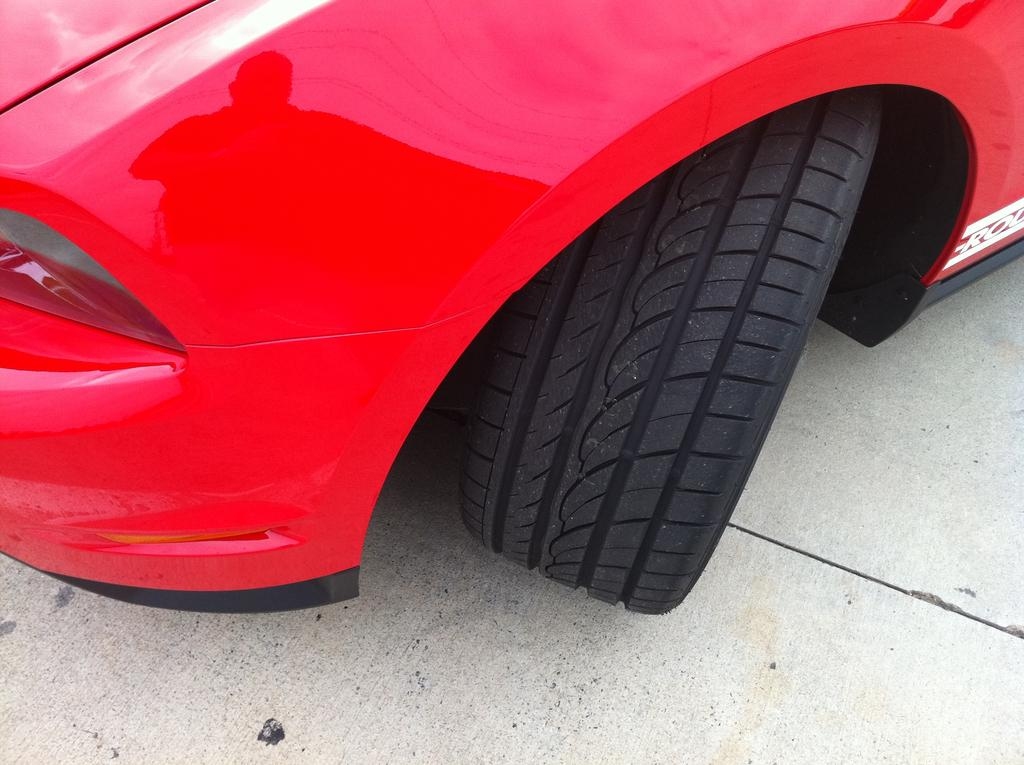What color is the vehicle in the image? The vehicle in the image is red. What can be seen on the wheels of the vehicle? The wheels of the vehicle are black. What is the vehicle resting on in the image? The vehicle is on a surface. Where is the drawer located in the image? There is no drawer present in the image. How much credit is available for the vehicle in the image? There is no information about credit available for the vehicle in the image. 